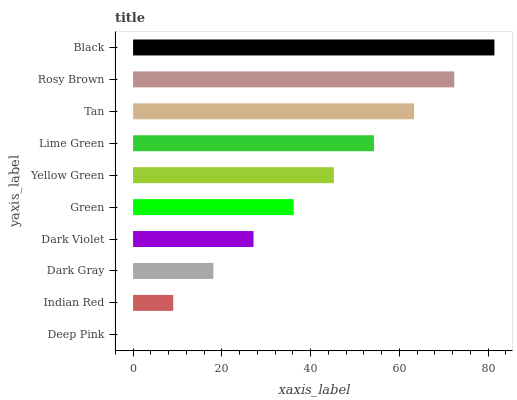Is Deep Pink the minimum?
Answer yes or no. Yes. Is Black the maximum?
Answer yes or no. Yes. Is Indian Red the minimum?
Answer yes or no. No. Is Indian Red the maximum?
Answer yes or no. No. Is Indian Red greater than Deep Pink?
Answer yes or no. Yes. Is Deep Pink less than Indian Red?
Answer yes or no. Yes. Is Deep Pink greater than Indian Red?
Answer yes or no. No. Is Indian Red less than Deep Pink?
Answer yes or no. No. Is Yellow Green the high median?
Answer yes or no. Yes. Is Green the low median?
Answer yes or no. Yes. Is Rosy Brown the high median?
Answer yes or no. No. Is Dark Gray the low median?
Answer yes or no. No. 